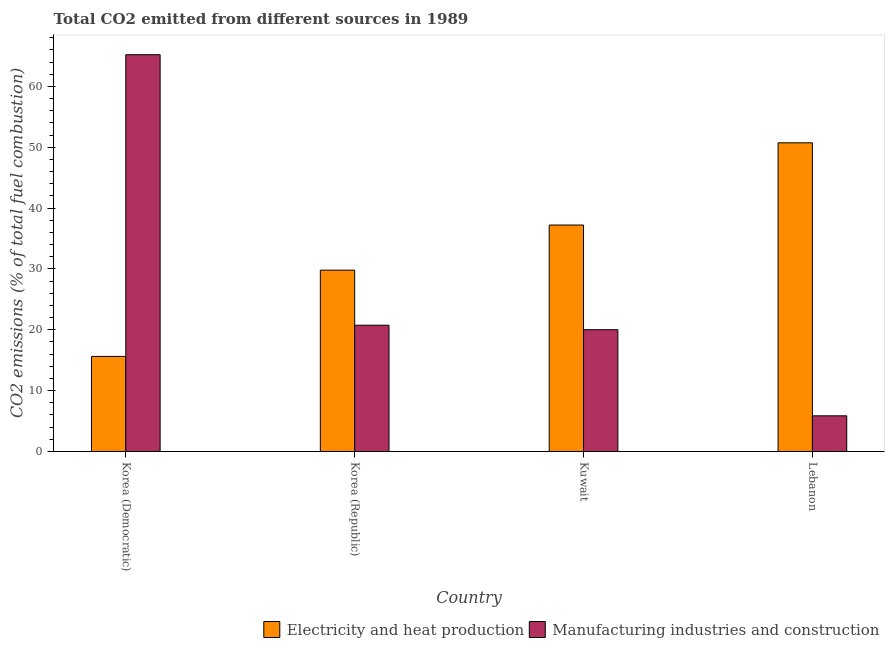How many different coloured bars are there?
Make the answer very short. 2. How many groups of bars are there?
Give a very brief answer. 4. Are the number of bars per tick equal to the number of legend labels?
Give a very brief answer. Yes. Are the number of bars on each tick of the X-axis equal?
Give a very brief answer. Yes. How many bars are there on the 2nd tick from the right?
Make the answer very short. 2. What is the label of the 2nd group of bars from the left?
Keep it short and to the point. Korea (Republic). In how many cases, is the number of bars for a given country not equal to the number of legend labels?
Offer a very short reply. 0. What is the co2 emissions due to manufacturing industries in Korea (Republic)?
Offer a very short reply. 20.75. Across all countries, what is the maximum co2 emissions due to electricity and heat production?
Offer a terse response. 50.73. Across all countries, what is the minimum co2 emissions due to manufacturing industries?
Offer a very short reply. 5.86. In which country was the co2 emissions due to manufacturing industries maximum?
Your response must be concise. Korea (Democratic). In which country was the co2 emissions due to electricity and heat production minimum?
Ensure brevity in your answer.  Korea (Democratic). What is the total co2 emissions due to manufacturing industries in the graph?
Provide a succinct answer. 111.84. What is the difference between the co2 emissions due to manufacturing industries in Korea (Republic) and that in Lebanon?
Offer a very short reply. 14.89. What is the difference between the co2 emissions due to electricity and heat production in Korea (Democratic) and the co2 emissions due to manufacturing industries in Lebanon?
Make the answer very short. 9.77. What is the average co2 emissions due to electricity and heat production per country?
Ensure brevity in your answer.  33.35. What is the difference between the co2 emissions due to manufacturing industries and co2 emissions due to electricity and heat production in Kuwait?
Give a very brief answer. -17.2. What is the ratio of the co2 emissions due to electricity and heat production in Korea (Republic) to that in Kuwait?
Offer a very short reply. 0.8. What is the difference between the highest and the second highest co2 emissions due to manufacturing industries?
Give a very brief answer. 44.46. What is the difference between the highest and the lowest co2 emissions due to manufacturing industries?
Your response must be concise. 59.35. Is the sum of the co2 emissions due to electricity and heat production in Korea (Republic) and Kuwait greater than the maximum co2 emissions due to manufacturing industries across all countries?
Ensure brevity in your answer.  Yes. What does the 2nd bar from the left in Kuwait represents?
Your answer should be compact. Manufacturing industries and construction. What does the 1st bar from the right in Korea (Republic) represents?
Provide a succinct answer. Manufacturing industries and construction. How many bars are there?
Your response must be concise. 8. Are all the bars in the graph horizontal?
Your answer should be compact. No. Does the graph contain grids?
Your answer should be compact. No. Where does the legend appear in the graph?
Give a very brief answer. Bottom right. How many legend labels are there?
Provide a short and direct response. 2. How are the legend labels stacked?
Your response must be concise. Horizontal. What is the title of the graph?
Keep it short and to the point. Total CO2 emitted from different sources in 1989. Does "Female population" appear as one of the legend labels in the graph?
Offer a terse response. No. What is the label or title of the X-axis?
Ensure brevity in your answer.  Country. What is the label or title of the Y-axis?
Ensure brevity in your answer.  CO2 emissions (% of total fuel combustion). What is the CO2 emissions (% of total fuel combustion) of Electricity and heat production in Korea (Democratic)?
Ensure brevity in your answer.  15.63. What is the CO2 emissions (% of total fuel combustion) of Manufacturing industries and construction in Korea (Democratic)?
Ensure brevity in your answer.  65.21. What is the CO2 emissions (% of total fuel combustion) of Electricity and heat production in Korea (Republic)?
Keep it short and to the point. 29.8. What is the CO2 emissions (% of total fuel combustion) in Manufacturing industries and construction in Korea (Republic)?
Ensure brevity in your answer.  20.75. What is the CO2 emissions (% of total fuel combustion) of Electricity and heat production in Kuwait?
Your answer should be very brief. 37.22. What is the CO2 emissions (% of total fuel combustion) in Manufacturing industries and construction in Kuwait?
Your response must be concise. 20.02. What is the CO2 emissions (% of total fuel combustion) of Electricity and heat production in Lebanon?
Make the answer very short. 50.73. What is the CO2 emissions (% of total fuel combustion) of Manufacturing industries and construction in Lebanon?
Provide a succinct answer. 5.86. Across all countries, what is the maximum CO2 emissions (% of total fuel combustion) of Electricity and heat production?
Your response must be concise. 50.73. Across all countries, what is the maximum CO2 emissions (% of total fuel combustion) of Manufacturing industries and construction?
Ensure brevity in your answer.  65.21. Across all countries, what is the minimum CO2 emissions (% of total fuel combustion) of Electricity and heat production?
Keep it short and to the point. 15.63. Across all countries, what is the minimum CO2 emissions (% of total fuel combustion) in Manufacturing industries and construction?
Keep it short and to the point. 5.86. What is the total CO2 emissions (% of total fuel combustion) of Electricity and heat production in the graph?
Provide a short and direct response. 133.38. What is the total CO2 emissions (% of total fuel combustion) in Manufacturing industries and construction in the graph?
Your answer should be very brief. 111.84. What is the difference between the CO2 emissions (% of total fuel combustion) in Electricity and heat production in Korea (Democratic) and that in Korea (Republic)?
Provide a succinct answer. -14.18. What is the difference between the CO2 emissions (% of total fuel combustion) in Manufacturing industries and construction in Korea (Democratic) and that in Korea (Republic)?
Provide a short and direct response. 44.46. What is the difference between the CO2 emissions (% of total fuel combustion) in Electricity and heat production in Korea (Democratic) and that in Kuwait?
Offer a terse response. -21.59. What is the difference between the CO2 emissions (% of total fuel combustion) in Manufacturing industries and construction in Korea (Democratic) and that in Kuwait?
Your answer should be compact. 45.2. What is the difference between the CO2 emissions (% of total fuel combustion) in Electricity and heat production in Korea (Democratic) and that in Lebanon?
Offer a very short reply. -35.11. What is the difference between the CO2 emissions (% of total fuel combustion) of Manufacturing industries and construction in Korea (Democratic) and that in Lebanon?
Provide a short and direct response. 59.35. What is the difference between the CO2 emissions (% of total fuel combustion) of Electricity and heat production in Korea (Republic) and that in Kuwait?
Your answer should be compact. -7.41. What is the difference between the CO2 emissions (% of total fuel combustion) of Manufacturing industries and construction in Korea (Republic) and that in Kuwait?
Your answer should be very brief. 0.74. What is the difference between the CO2 emissions (% of total fuel combustion) of Electricity and heat production in Korea (Republic) and that in Lebanon?
Give a very brief answer. -20.93. What is the difference between the CO2 emissions (% of total fuel combustion) of Manufacturing industries and construction in Korea (Republic) and that in Lebanon?
Provide a short and direct response. 14.89. What is the difference between the CO2 emissions (% of total fuel combustion) of Electricity and heat production in Kuwait and that in Lebanon?
Make the answer very short. -13.51. What is the difference between the CO2 emissions (% of total fuel combustion) of Manufacturing industries and construction in Kuwait and that in Lebanon?
Provide a short and direct response. 14.16. What is the difference between the CO2 emissions (% of total fuel combustion) in Electricity and heat production in Korea (Democratic) and the CO2 emissions (% of total fuel combustion) in Manufacturing industries and construction in Korea (Republic)?
Your answer should be very brief. -5.13. What is the difference between the CO2 emissions (% of total fuel combustion) of Electricity and heat production in Korea (Democratic) and the CO2 emissions (% of total fuel combustion) of Manufacturing industries and construction in Kuwait?
Make the answer very short. -4.39. What is the difference between the CO2 emissions (% of total fuel combustion) of Electricity and heat production in Korea (Democratic) and the CO2 emissions (% of total fuel combustion) of Manufacturing industries and construction in Lebanon?
Give a very brief answer. 9.77. What is the difference between the CO2 emissions (% of total fuel combustion) in Electricity and heat production in Korea (Republic) and the CO2 emissions (% of total fuel combustion) in Manufacturing industries and construction in Kuwait?
Offer a very short reply. 9.79. What is the difference between the CO2 emissions (% of total fuel combustion) of Electricity and heat production in Korea (Republic) and the CO2 emissions (% of total fuel combustion) of Manufacturing industries and construction in Lebanon?
Ensure brevity in your answer.  23.94. What is the difference between the CO2 emissions (% of total fuel combustion) in Electricity and heat production in Kuwait and the CO2 emissions (% of total fuel combustion) in Manufacturing industries and construction in Lebanon?
Offer a very short reply. 31.36. What is the average CO2 emissions (% of total fuel combustion) in Electricity and heat production per country?
Ensure brevity in your answer.  33.34. What is the average CO2 emissions (% of total fuel combustion) of Manufacturing industries and construction per country?
Your response must be concise. 27.96. What is the difference between the CO2 emissions (% of total fuel combustion) of Electricity and heat production and CO2 emissions (% of total fuel combustion) of Manufacturing industries and construction in Korea (Democratic)?
Offer a terse response. -49.59. What is the difference between the CO2 emissions (% of total fuel combustion) in Electricity and heat production and CO2 emissions (% of total fuel combustion) in Manufacturing industries and construction in Korea (Republic)?
Offer a very short reply. 9.05. What is the difference between the CO2 emissions (% of total fuel combustion) of Electricity and heat production and CO2 emissions (% of total fuel combustion) of Manufacturing industries and construction in Kuwait?
Ensure brevity in your answer.  17.2. What is the difference between the CO2 emissions (% of total fuel combustion) in Electricity and heat production and CO2 emissions (% of total fuel combustion) in Manufacturing industries and construction in Lebanon?
Your response must be concise. 44.87. What is the ratio of the CO2 emissions (% of total fuel combustion) of Electricity and heat production in Korea (Democratic) to that in Korea (Republic)?
Your answer should be very brief. 0.52. What is the ratio of the CO2 emissions (% of total fuel combustion) of Manufacturing industries and construction in Korea (Democratic) to that in Korea (Republic)?
Provide a short and direct response. 3.14. What is the ratio of the CO2 emissions (% of total fuel combustion) in Electricity and heat production in Korea (Democratic) to that in Kuwait?
Make the answer very short. 0.42. What is the ratio of the CO2 emissions (% of total fuel combustion) of Manufacturing industries and construction in Korea (Democratic) to that in Kuwait?
Ensure brevity in your answer.  3.26. What is the ratio of the CO2 emissions (% of total fuel combustion) in Electricity and heat production in Korea (Democratic) to that in Lebanon?
Offer a terse response. 0.31. What is the ratio of the CO2 emissions (% of total fuel combustion) in Manufacturing industries and construction in Korea (Democratic) to that in Lebanon?
Ensure brevity in your answer.  11.13. What is the ratio of the CO2 emissions (% of total fuel combustion) in Electricity and heat production in Korea (Republic) to that in Kuwait?
Offer a terse response. 0.8. What is the ratio of the CO2 emissions (% of total fuel combustion) of Manufacturing industries and construction in Korea (Republic) to that in Kuwait?
Make the answer very short. 1.04. What is the ratio of the CO2 emissions (% of total fuel combustion) in Electricity and heat production in Korea (Republic) to that in Lebanon?
Your answer should be compact. 0.59. What is the ratio of the CO2 emissions (% of total fuel combustion) in Manufacturing industries and construction in Korea (Republic) to that in Lebanon?
Provide a succinct answer. 3.54. What is the ratio of the CO2 emissions (% of total fuel combustion) in Electricity and heat production in Kuwait to that in Lebanon?
Your response must be concise. 0.73. What is the ratio of the CO2 emissions (% of total fuel combustion) of Manufacturing industries and construction in Kuwait to that in Lebanon?
Make the answer very short. 3.42. What is the difference between the highest and the second highest CO2 emissions (% of total fuel combustion) of Electricity and heat production?
Offer a terse response. 13.51. What is the difference between the highest and the second highest CO2 emissions (% of total fuel combustion) in Manufacturing industries and construction?
Ensure brevity in your answer.  44.46. What is the difference between the highest and the lowest CO2 emissions (% of total fuel combustion) of Electricity and heat production?
Your answer should be compact. 35.11. What is the difference between the highest and the lowest CO2 emissions (% of total fuel combustion) of Manufacturing industries and construction?
Provide a short and direct response. 59.35. 